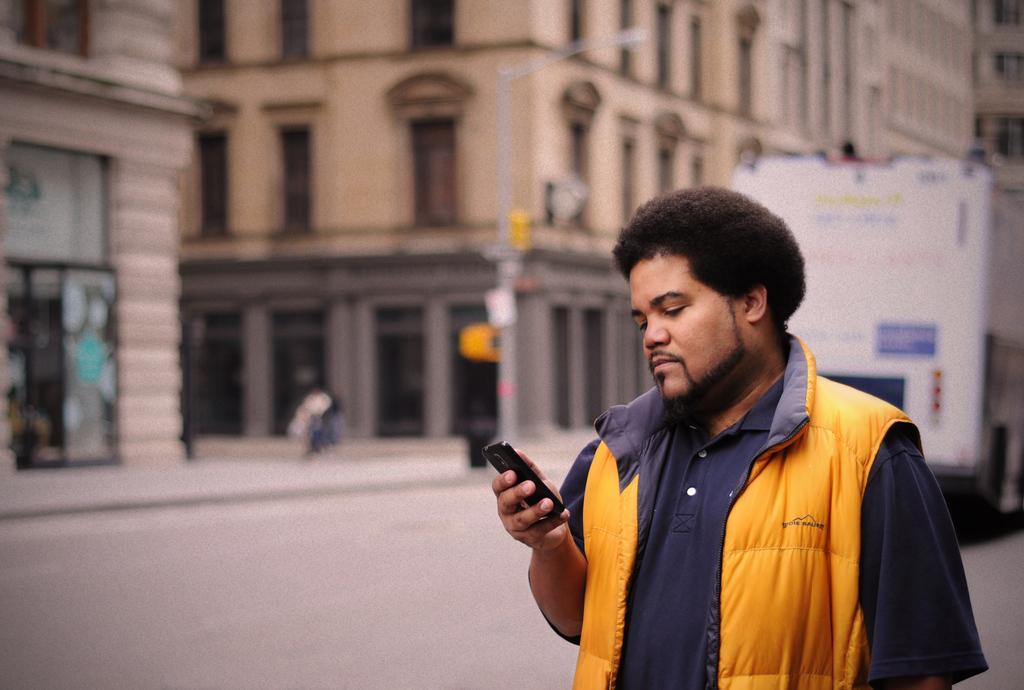Describe this image in one or two sentences. In this image I can see a person is holding the mobile and wearing blue and yellow color dress. Back I can see few buildings, light pole and vehicle. 